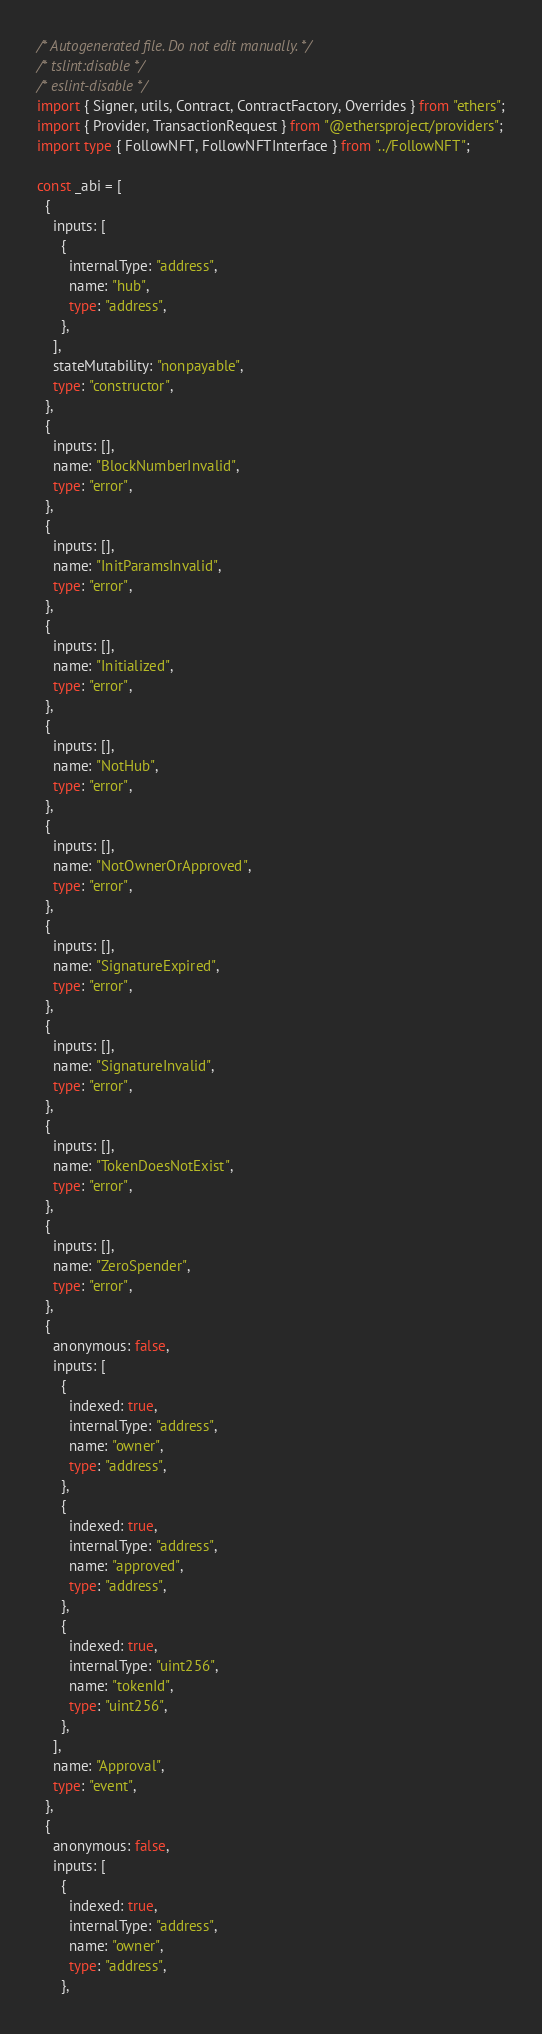Convert code to text. <code><loc_0><loc_0><loc_500><loc_500><_TypeScript_>/* Autogenerated file. Do not edit manually. */
/* tslint:disable */
/* eslint-disable */
import { Signer, utils, Contract, ContractFactory, Overrides } from "ethers";
import { Provider, TransactionRequest } from "@ethersproject/providers";
import type { FollowNFT, FollowNFTInterface } from "../FollowNFT";

const _abi = [
  {
    inputs: [
      {
        internalType: "address",
        name: "hub",
        type: "address",
      },
    ],
    stateMutability: "nonpayable",
    type: "constructor",
  },
  {
    inputs: [],
    name: "BlockNumberInvalid",
    type: "error",
  },
  {
    inputs: [],
    name: "InitParamsInvalid",
    type: "error",
  },
  {
    inputs: [],
    name: "Initialized",
    type: "error",
  },
  {
    inputs: [],
    name: "NotHub",
    type: "error",
  },
  {
    inputs: [],
    name: "NotOwnerOrApproved",
    type: "error",
  },
  {
    inputs: [],
    name: "SignatureExpired",
    type: "error",
  },
  {
    inputs: [],
    name: "SignatureInvalid",
    type: "error",
  },
  {
    inputs: [],
    name: "TokenDoesNotExist",
    type: "error",
  },
  {
    inputs: [],
    name: "ZeroSpender",
    type: "error",
  },
  {
    anonymous: false,
    inputs: [
      {
        indexed: true,
        internalType: "address",
        name: "owner",
        type: "address",
      },
      {
        indexed: true,
        internalType: "address",
        name: "approved",
        type: "address",
      },
      {
        indexed: true,
        internalType: "uint256",
        name: "tokenId",
        type: "uint256",
      },
    ],
    name: "Approval",
    type: "event",
  },
  {
    anonymous: false,
    inputs: [
      {
        indexed: true,
        internalType: "address",
        name: "owner",
        type: "address",
      },</code> 